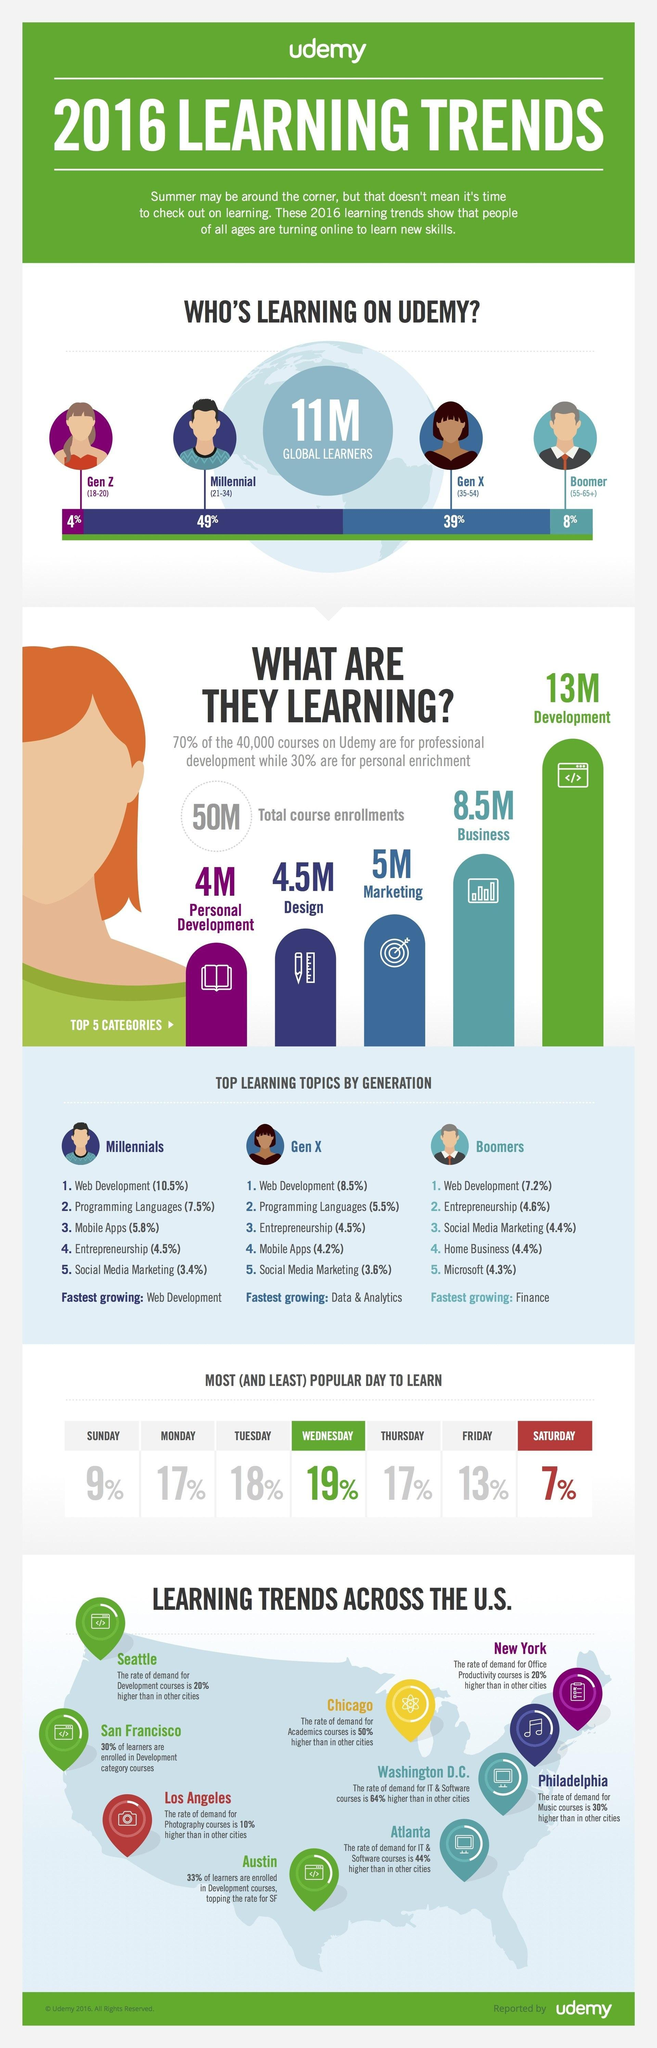Which cities in the US have a demand for enrolling in IT & Software courses courses?
Answer the question with a short phrase. Washington D.C., Atlanta What is the second most preferred course among Millennials and Gen X? Programming Languages Which topic is the fifth most preferred by Millenials and Gen X, and is the third most preferred by Boomers? Social Media Marketing Which is the most preferred day for learning? Wednesday Which is the least preferred day for learning? Saturday What percentage of people prefer to learn on Mondays and Thursdays? 17% What percentage of people belonging to Gen X use Udemy for learning, 4%, 49%, or 39%? 39% Out of the 11 million global learners, which category of people use Udemy as a platform for learning the most? Millenials Which is the most preferred course among, Millenials, GenX, and Boomers? Web Development Which cities in the US have maximum demand for enrolling in development courses? Seattle, San Francisco, Austin 